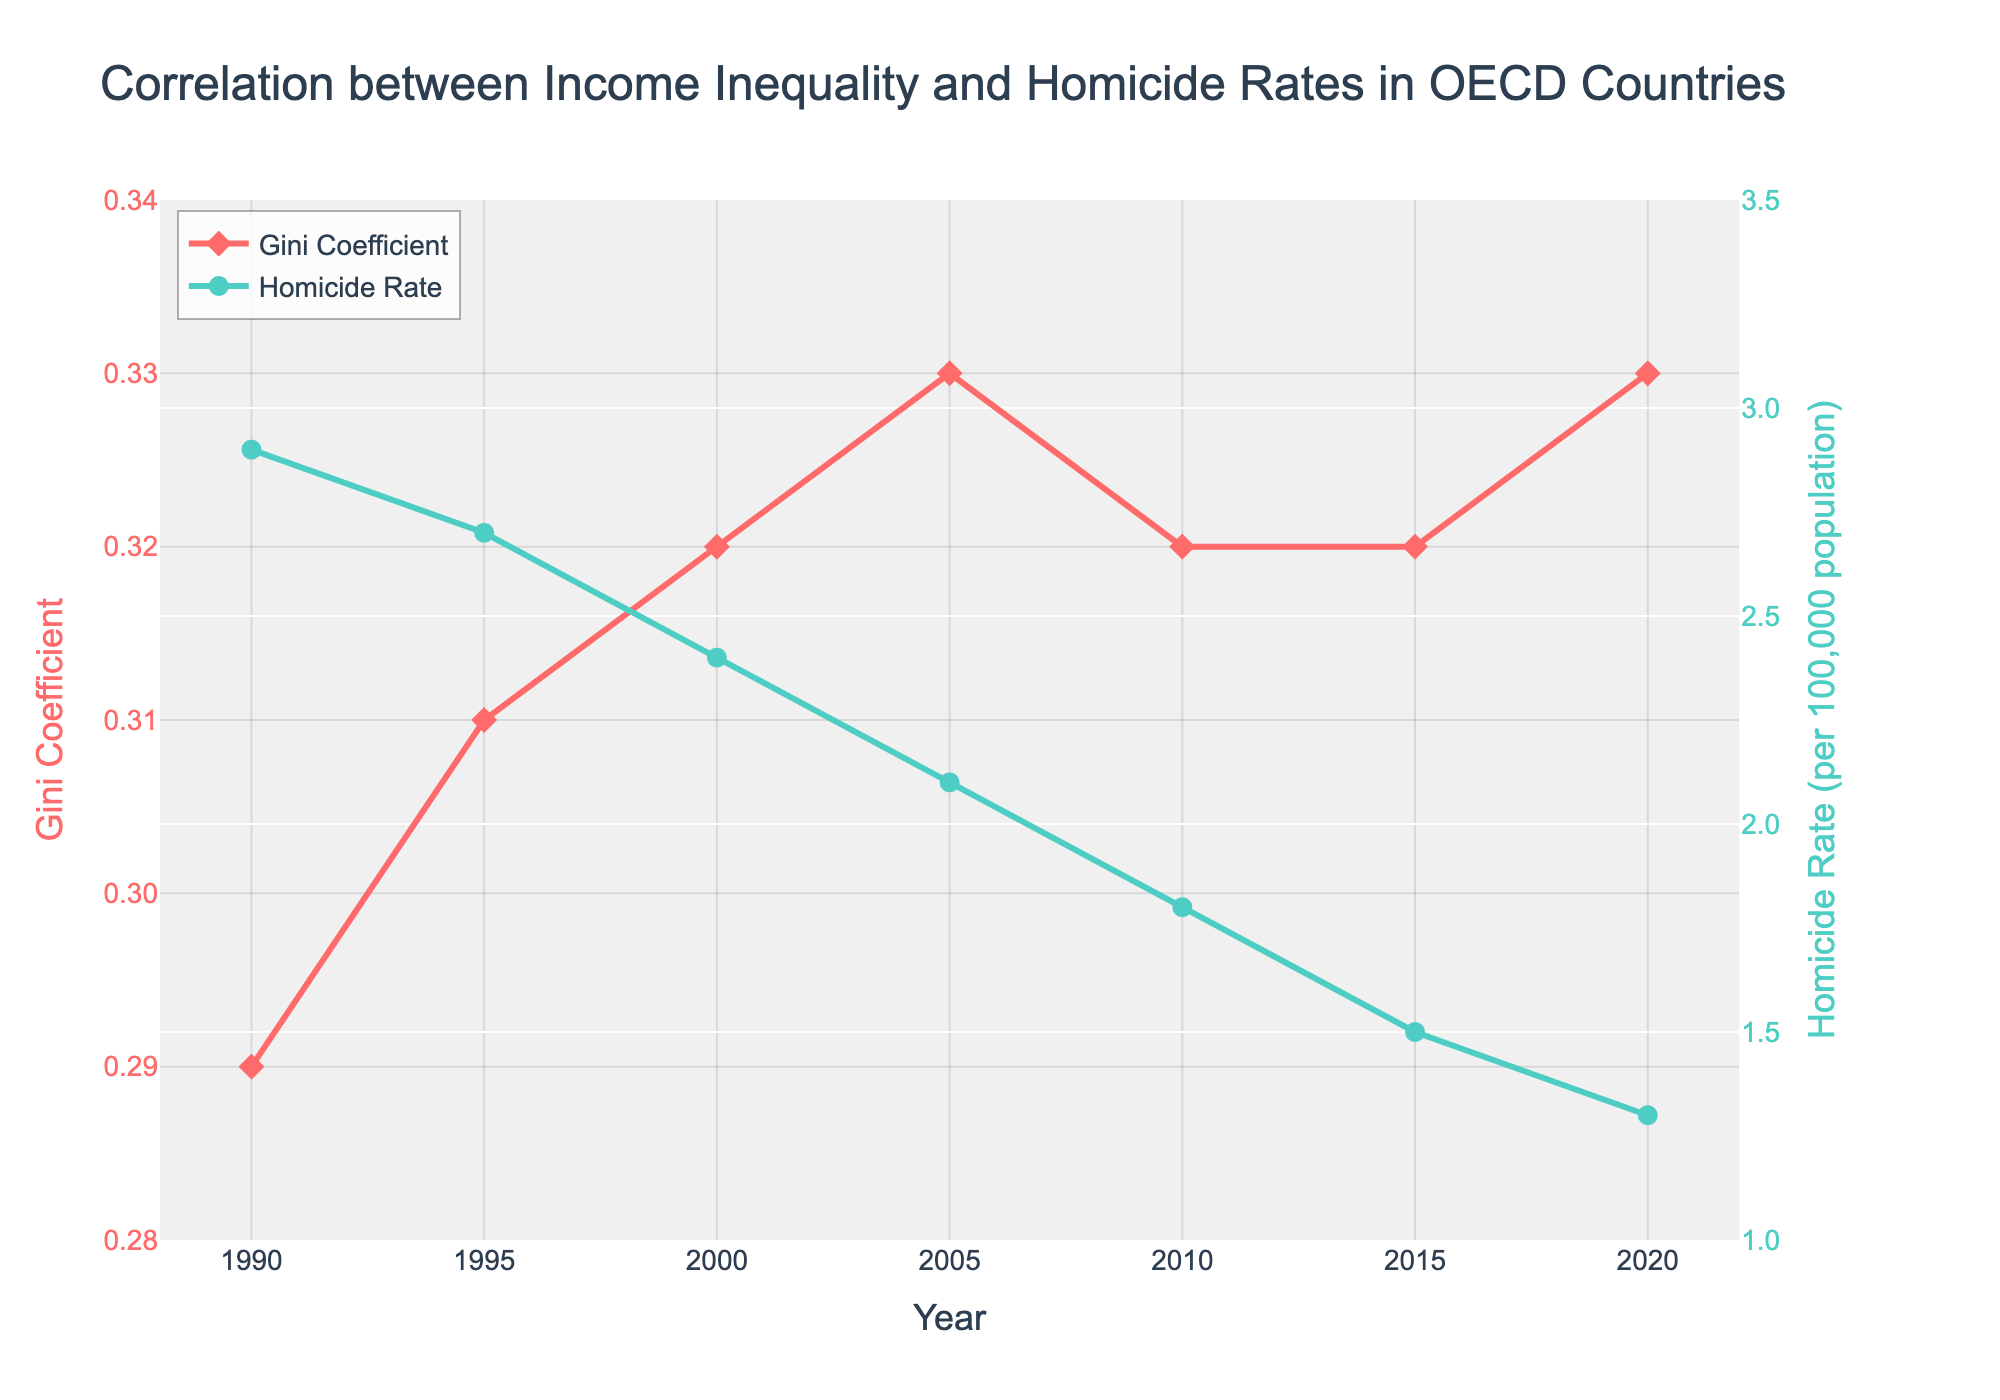What is the trend in the Gini coefficient from 1990 to 2020? The Gini coefficient generally increased from 0.29 in 1990 to 0.33 in 2020, with minor fluctuations.
Answer: Increasing Between which years did the homicide rate decrease the most? The homicide rate showed the most significant decrease between 2005 and 2010, dropping from 2.1 to 1.8.
Answer: 2005 to 2010 What is the difference in the Gini coefficient between 1990 and 2020? Subtract the Gini coefficient in 1990 from that in 2020 (0.33 - 0.29).
Answer: 0.04 Compare the Gini coefficient and the homicide rate in 2005. Which is higher? The Gini coefficient is 0.33 and the homicide rate is 2.1 per 100,000 population. Since these are on different scales, this comparison can't imply 'higher' in a direct sense without context.
Answer: Not directly comparable What is the average Gini coefficient over these years? Average equals the sum of Gini coefficients divided by the number of years: (0.29 + 0.31 + 0.32 + 0.33 + 0.32 + 0.32 + 0.33) / 7.
Answer: 0.317 Which year shows the lowest homicide rate, and what is the value? The lowest homicide rate is in 2020, with a value of 1.3 per 100,000 population.
Answer: 2020, 1.3 What are the visual attributes of the Gini coefficient line on the plot? The Gini coefficient line is red, uses diamond-shaped markers, and has a line width of 3.
Answer: Red, diamond-shaped markers, line width 3 By how much did the homicide rate change from 1990 to 2010? Subtract the homicide rate in 2010 from that in 1990 (2.9 - 1.8).
Answer: 1.1 Is there any period where the Gini coefficient remained constant? The Gini coefficient remained constant at 0.32 from 2000 to 2005 and from 2010 to 2015.
Answer: 2000 to 2005 and 2010 to 2015 Which year had the highest Gini coefficient, and what was the corresponding homicide rate? The highest Gini coefficient (0.33) was in 2005 and 2020, with corresponding homicide rates of 2.1 and 1.3, respectively.
Answer: 2005, 2020 → 2.1, 1.3 